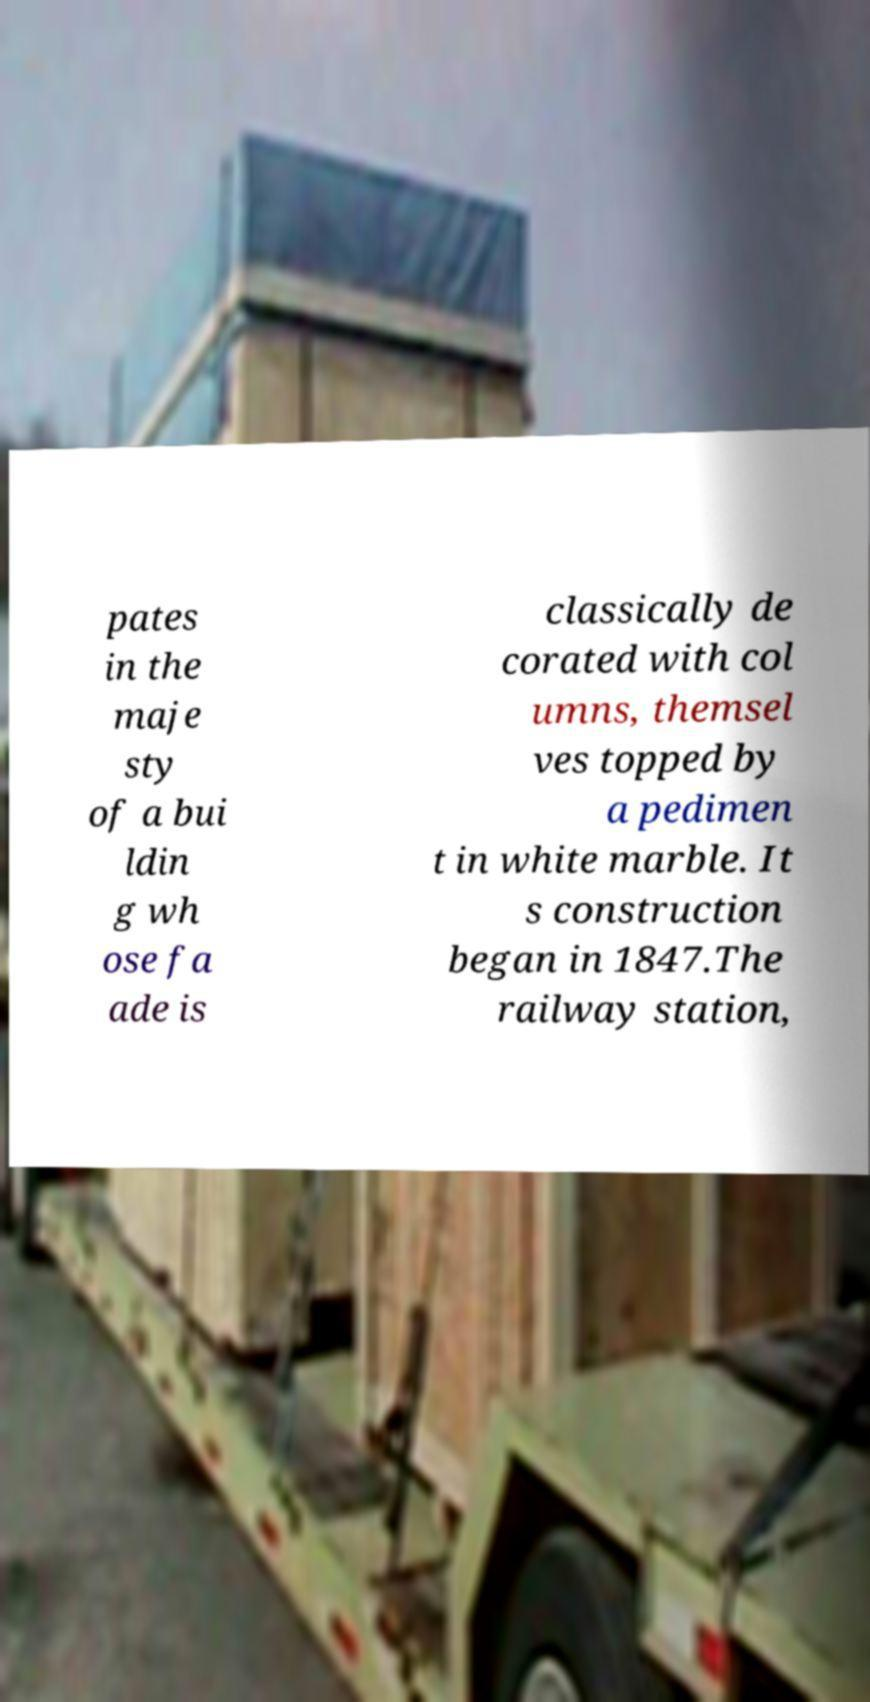Could you extract and type out the text from this image? pates in the maje sty of a bui ldin g wh ose fa ade is classically de corated with col umns, themsel ves topped by a pedimen t in white marble. It s construction began in 1847.The railway station, 